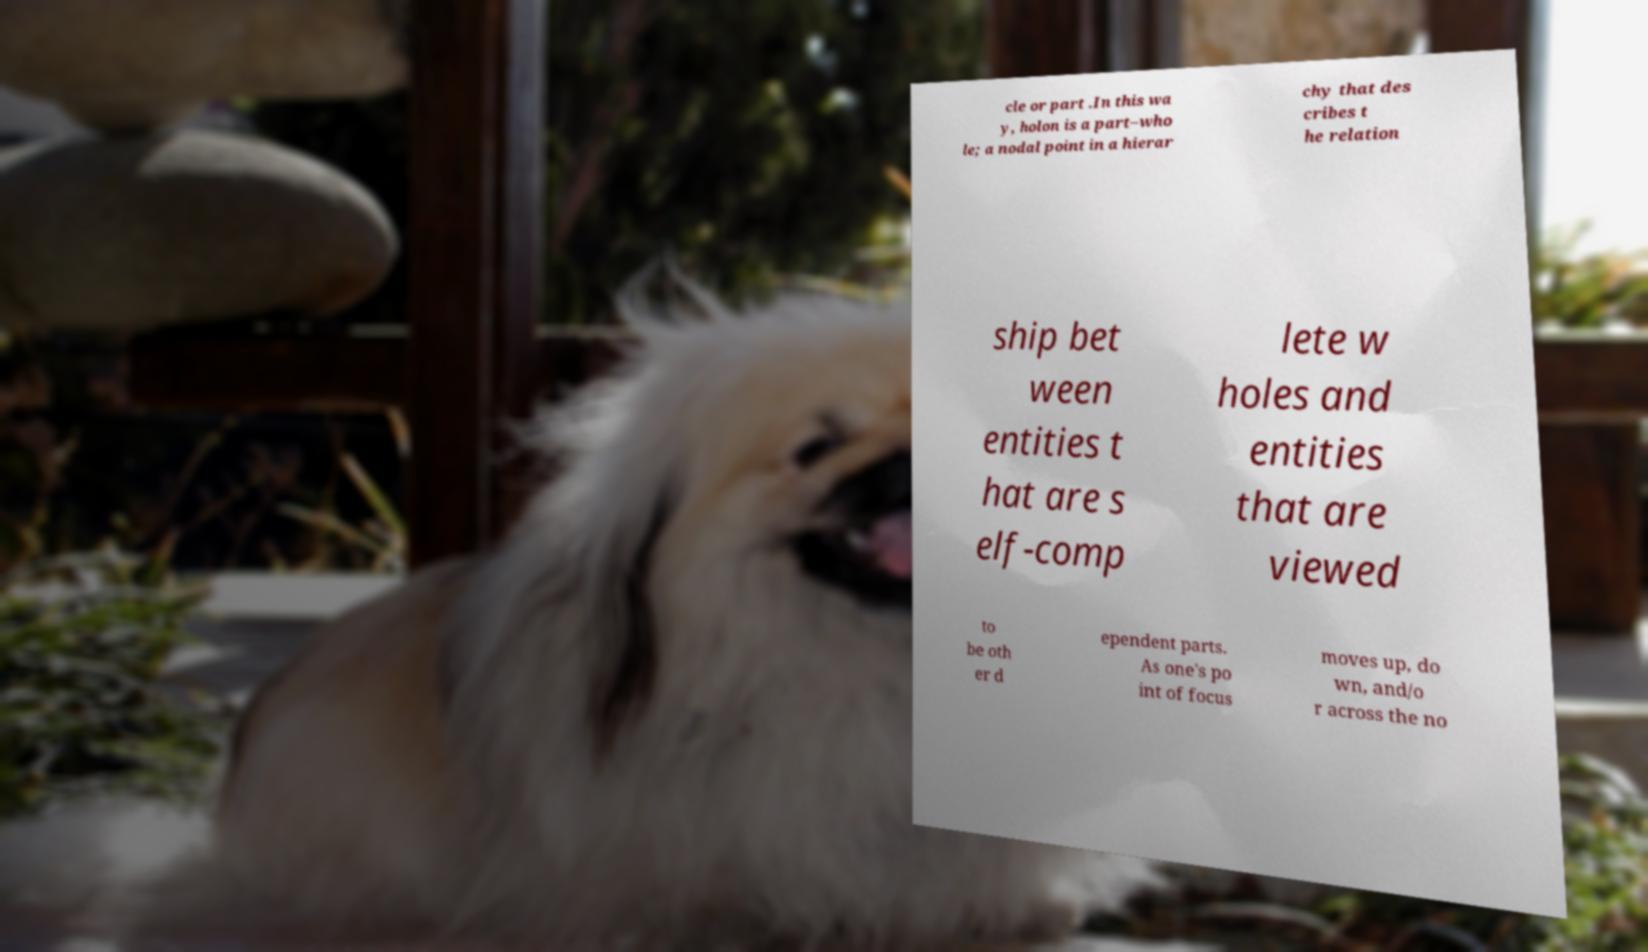I need the written content from this picture converted into text. Can you do that? cle or part .In this wa y, holon is a part–who le; a nodal point in a hierar chy that des cribes t he relation ship bet ween entities t hat are s elf-comp lete w holes and entities that are viewed to be oth er d ependent parts. As one's po int of focus moves up, do wn, and/o r across the no 